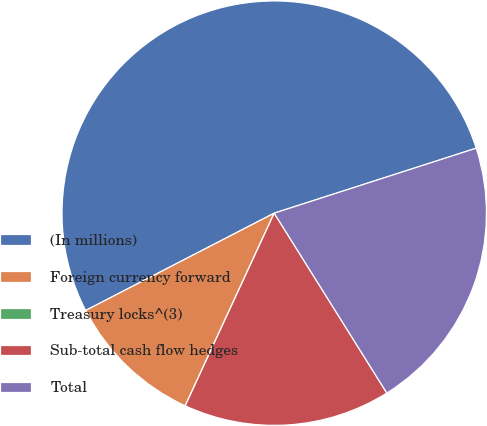<chart> <loc_0><loc_0><loc_500><loc_500><pie_chart><fcel>(In millions)<fcel>Foreign currency forward<fcel>Treasury locks^(3)<fcel>Sub-total cash flow hedges<fcel>Total<nl><fcel>52.63%<fcel>10.53%<fcel>0.0%<fcel>15.79%<fcel>21.05%<nl></chart> 